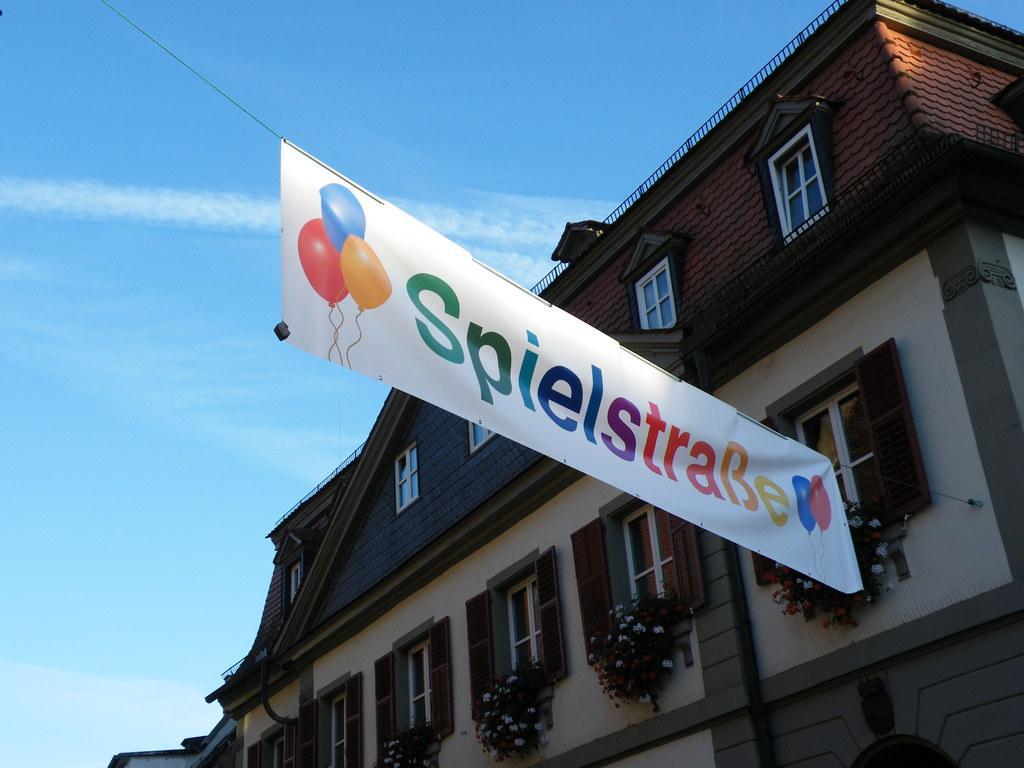Please provide a concise description of this image. In this image, we can see a building and windows with flower pots and there is a banner. 